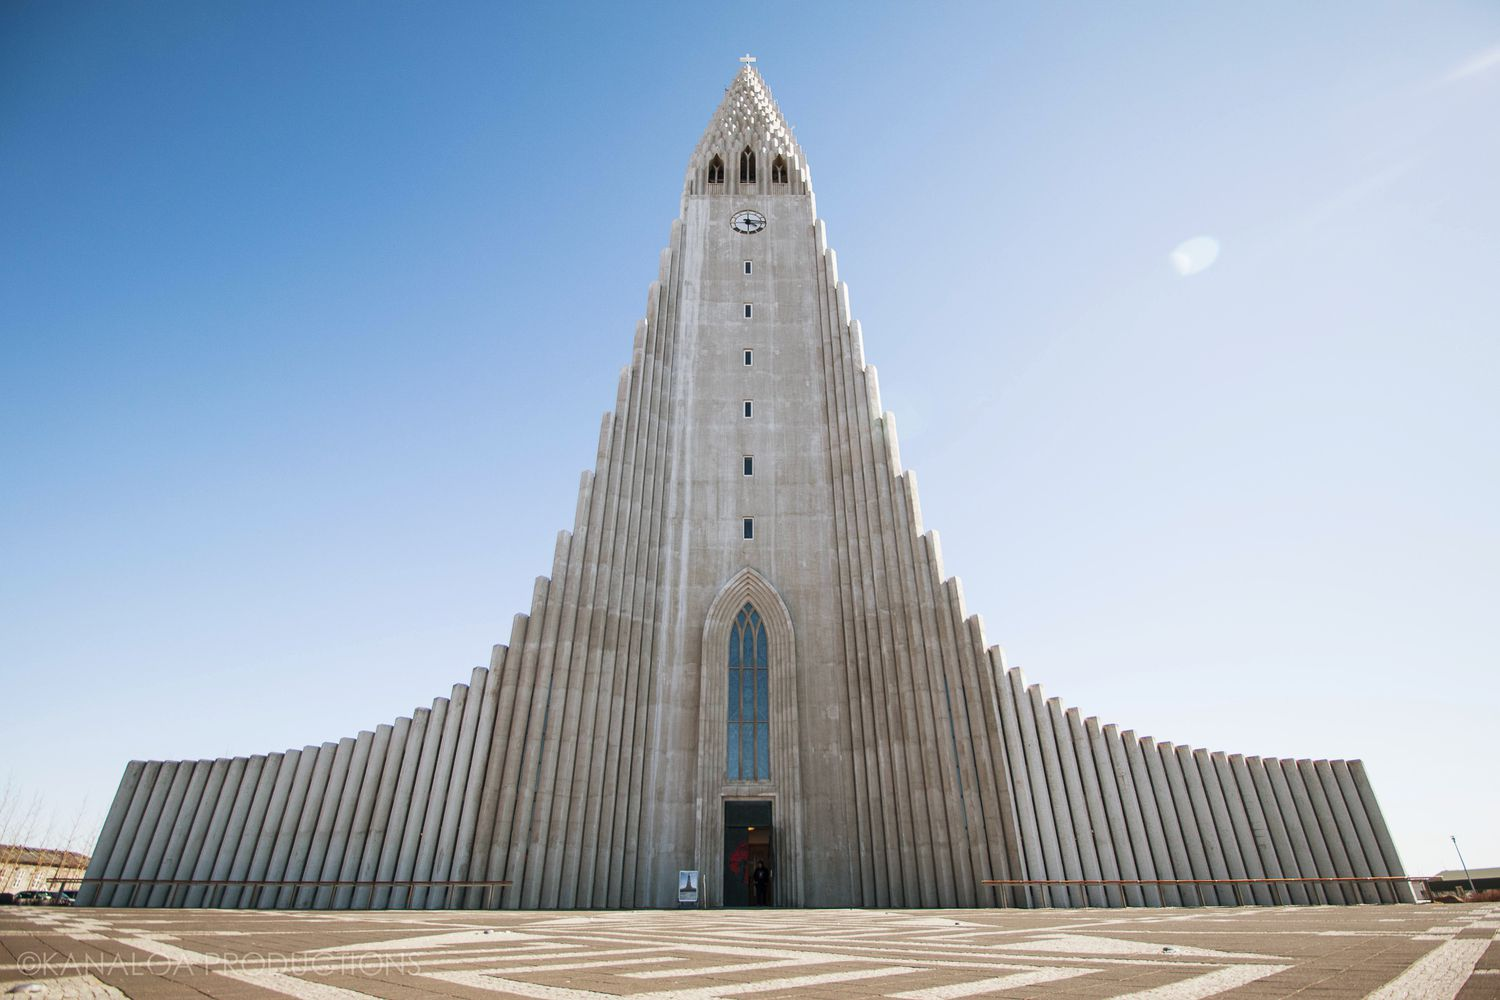What would be a poetic interpretation of this image? Rising like a silhouette against the heavens, Hallgrímskirkja pierces the cerulean sky, a testament to human aspiration and divine inspiration. Its gray facade, a silent guardian of stories untold, stands in solemn vigil. The cross, aloft and timeless, catches the first and last light of the day, symbolizing hope and eternity. Beneath, the red door beckons weary souls, promising sanctuary and renewal. In the stillness, the church whispers of reverence, a sacred symphony of stone and sky. Here, beneath the vast Icelandic skies, one feels the whisper of the infinite and the embrace of the eternal. 